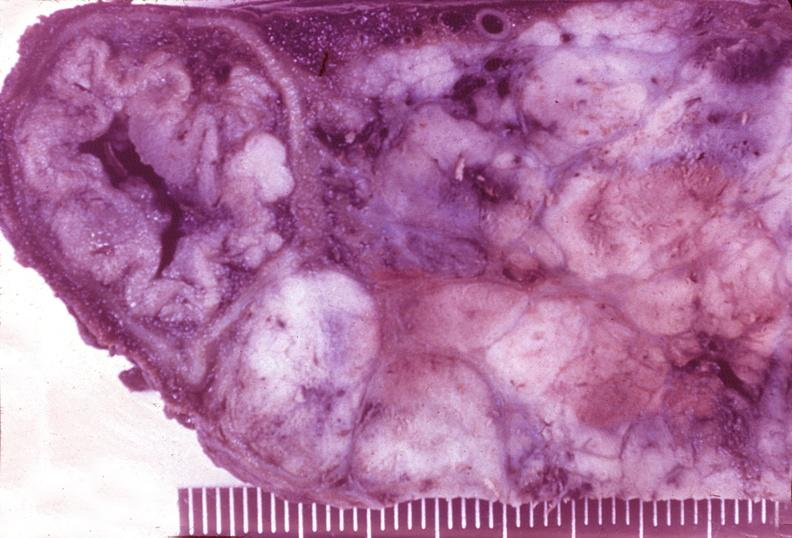does this image show islet cell carcinoma?
Answer the question using a single word or phrase. Yes 